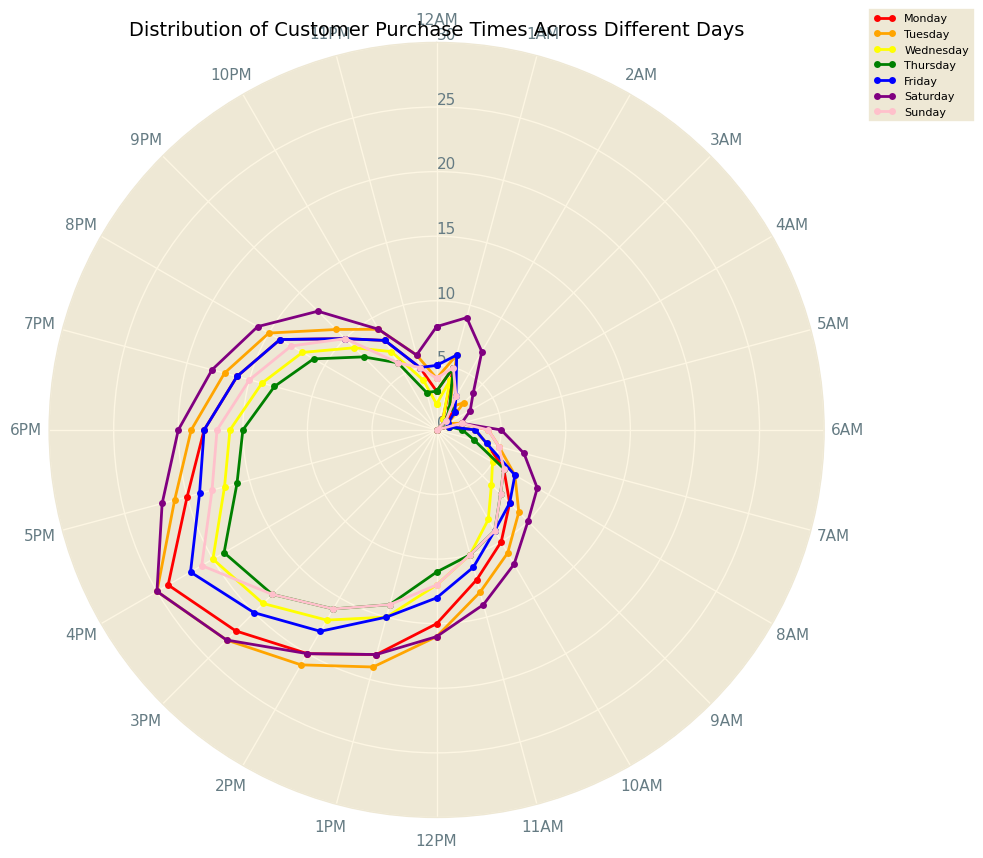How does the number of purchases on Monday at 10 AM compare to those on Wednesday at the same time? Check the lines for Monday and Wednesday on the rose chart at the 10 AM mark. The height of the points at 10 AM will indicate the purchase counts. Monday has 10 purchases, while Wednesday has 8 purchases.
Answer: Monday has more What day has the highest purchase count at 3 PM? Look at the 3 PM markers for all days. The day with the highest point at 3 PM will indicate the highest purchase count. Saturday has the highest point at 3 PM.
Answer: Saturday Which day has the least purchase activities at 4 AM? Compare the points at 4 AM for all days. The day with the lowest point indicates the least purchase activity. Monday and Thursday both show zero purchases at 4 AM.
Answer: Monday and Thursday Which day shows a significant increase in purchases from 8 AM to 12 PM? Observe the lines for each day from 8 AM to 12 PM. Identify the day with the steepest upward trend. Monday shows a significant increase from 8 purchases at 8 AM to 15 purchases at 12 PM.
Answer: Monday On which day does the purchase count at 6 PM match the purchase count at 9 PM? Compare the 6 PM and 9 PM markers for all days. Look for the day where both markers have the same height. Tuesday shows a match with 17 purchases at both 6 PM and 9 PM.
Answer: Tuesday What is the average purchase count at 11 AM across all days? Sum the purchase counts at 11 AM for all days and divide by the number of days. (12 + 13 + 10 + 10 + 11 + 14 + 10) / 7 = 80 / 7 ≈ 11.43.
Answer: 11.43 How does the purchase activity on Friday at 2 AM compare to Saturday at the same hour? Check the lines for Friday and Saturday at the 2 AM mark. The height of the points at 2 AM will indicate the purchase counts. Friday has 3 purchases, while Saturday has 7 purchases.
Answer: Saturday has more Which day has the highest purchase count at any hour, and at what time? Identify the day and hour marker with the maximum height on the rose chart. Saturday has the highest purchase count at 4 PM with 25 purchases.
Answer: Saturday at 4 PM What is the combined purchase count for Sunday at 1 PM and Tuesday at 2 PM? Add the purchase counts for identified times. Sunday at 1 PM has 14 purchases and Tuesday at 2 PM has 2 purchases, so 14 + 2 = 16.
Answer: 16 